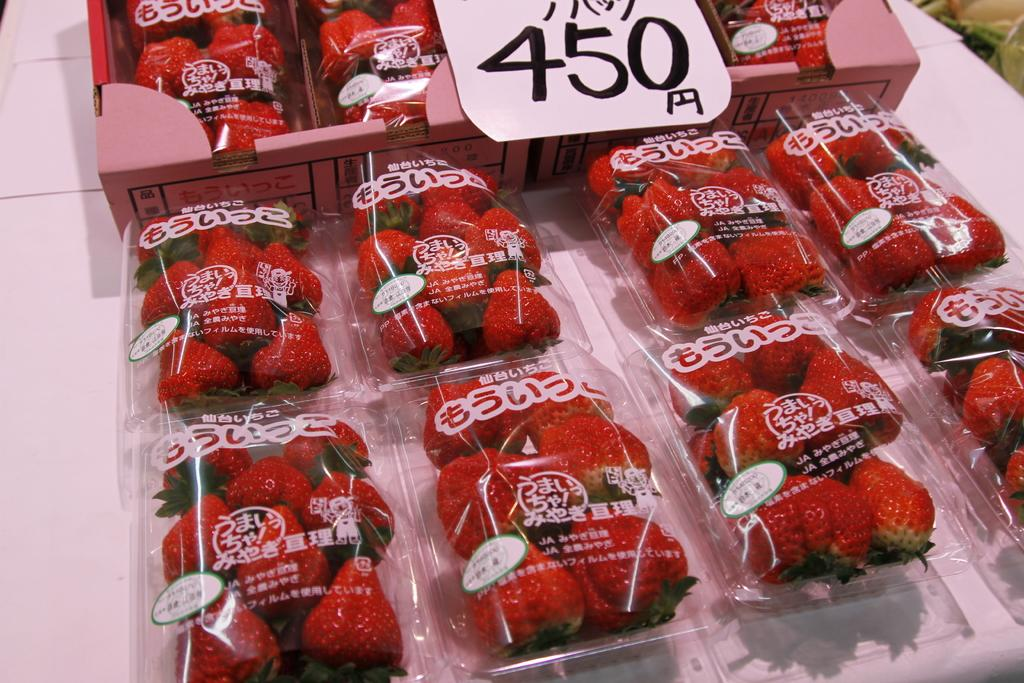What type of fruit is present in the image? There are strawberries in the image. How are the strawberries being stored or displayed? The strawberries are in boxes. Is there any information about the cost of the strawberries in the image? Yes, there is a price tag in the image. What type of bat can be seen flying near the strawberries in the image? There is no bat present in the image; it only features strawberries in boxes and a price tag. 